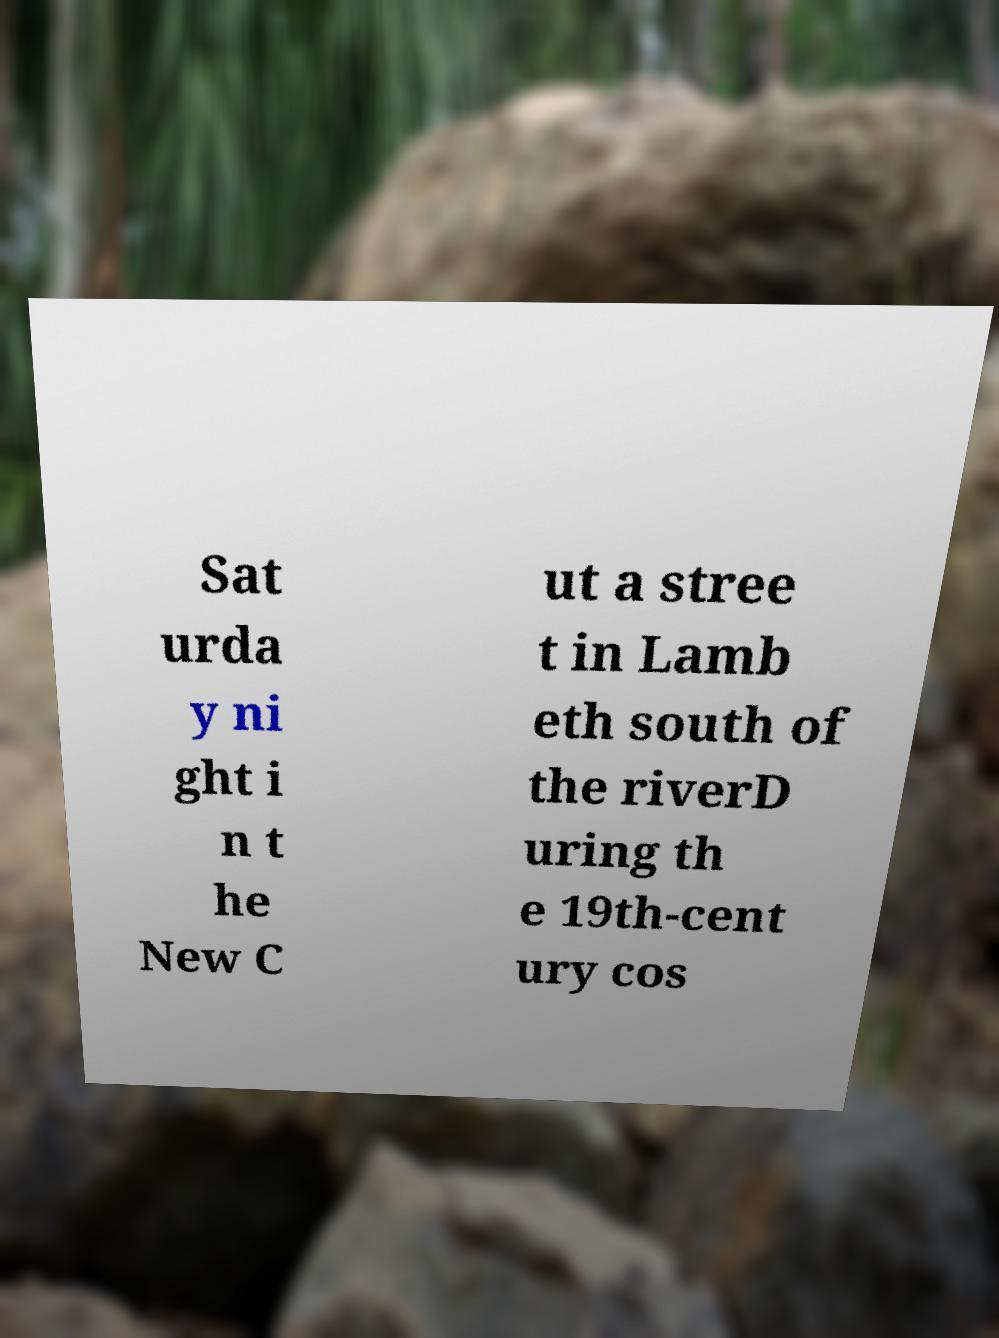I need the written content from this picture converted into text. Can you do that? Sat urda y ni ght i n t he New C ut a stree t in Lamb eth south of the riverD uring th e 19th-cent ury cos 